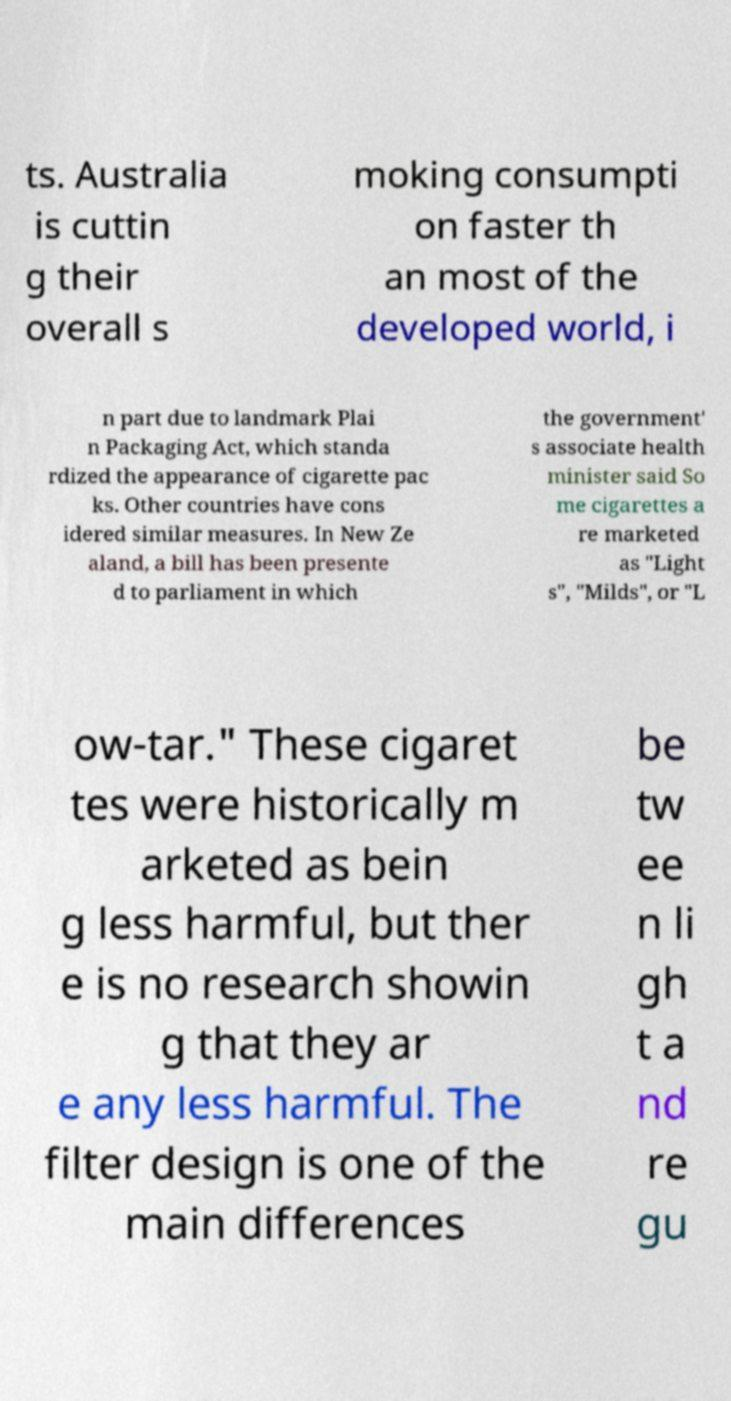Please identify and transcribe the text found in this image. ts. Australia is cuttin g their overall s moking consumpti on faster th an most of the developed world, i n part due to landmark Plai n Packaging Act, which standa rdized the appearance of cigarette pac ks. Other countries have cons idered similar measures. In New Ze aland, a bill has been presente d to parliament in which the government' s associate health minister said So me cigarettes a re marketed as "Light s", "Milds", or "L ow-tar." These cigaret tes were historically m arketed as bein g less harmful, but ther e is no research showin g that they ar e any less harmful. The filter design is one of the main differences be tw ee n li gh t a nd re gu 